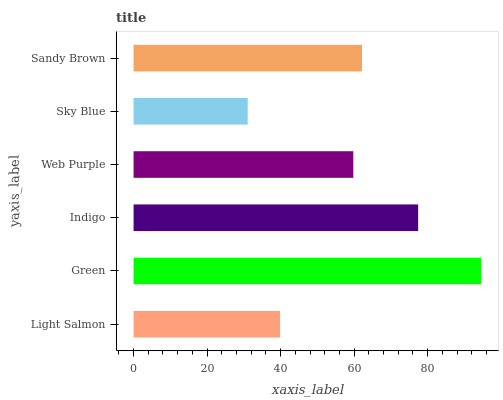Is Sky Blue the minimum?
Answer yes or no. Yes. Is Green the maximum?
Answer yes or no. Yes. Is Indigo the minimum?
Answer yes or no. No. Is Indigo the maximum?
Answer yes or no. No. Is Green greater than Indigo?
Answer yes or no. Yes. Is Indigo less than Green?
Answer yes or no. Yes. Is Indigo greater than Green?
Answer yes or no. No. Is Green less than Indigo?
Answer yes or no. No. Is Sandy Brown the high median?
Answer yes or no. Yes. Is Web Purple the low median?
Answer yes or no. Yes. Is Sky Blue the high median?
Answer yes or no. No. Is Sky Blue the low median?
Answer yes or no. No. 